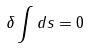Convert formula to latex. <formula><loc_0><loc_0><loc_500><loc_500>\delta \int d s = 0</formula> 